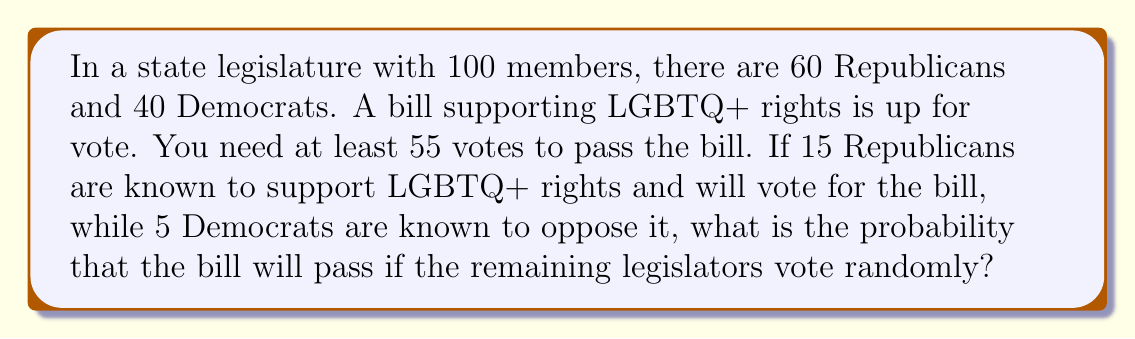Provide a solution to this math problem. Let's approach this step-by-step:

1) We know for certain that:
   - 15 Republicans will vote for the bill
   - 35 Democrats (40 - 5) will vote for the bill

2) This means we already have 50 guaranteed votes for the bill.

3) We need at least 5 more votes from the remaining legislators to reach the 55-vote threshold.

4) The remaining legislators who will vote randomly are:
   - 45 Republicans (60 - 15)
   - 5 Democrats (the ones known to oppose)

5) So, we have 50 legislators voting randomly. We need at least 5 of them to vote for the bill.

6) This scenario follows a binomial probability distribution. The probability of success (voting for the bill) for each random vote is 0.5 (50% chance).

7) We can calculate the probability of getting 5 or more votes out of 50 using the cumulative binomial probability formula:

   $$P(X \geq 5) = 1 - P(X < 5) = 1 - \sum_{k=0}^{4} \binom{50}{k} (0.5)^k (0.5)^{50-k}$$

8) Using a calculator or computer (as this involves a large sum), we find:

   $$P(X \geq 5) \approx 0.9999998$$
Answer: The probability that the bill will pass is approximately 0.9999998 or 99.99998%. 